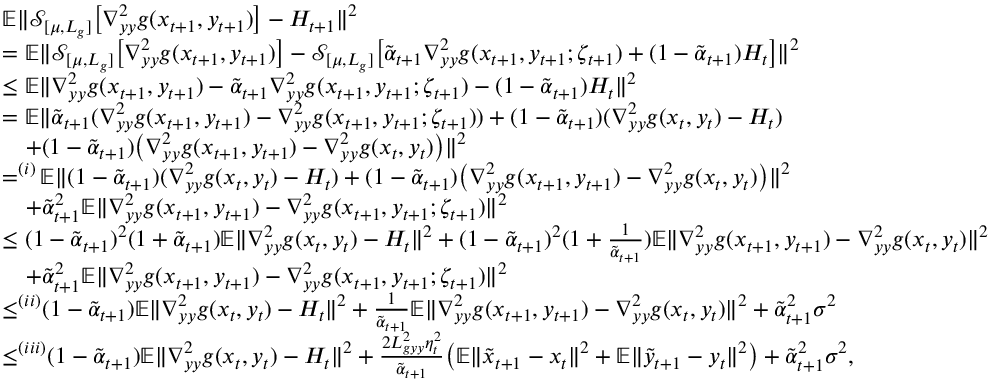<formula> <loc_0><loc_0><loc_500><loc_500>\begin{array} { r l } & { \mathbb { E } \| \mathcal { S } _ { [ \mu , L _ { g } ] } \left [ \nabla _ { y y } ^ { 2 } g ( x _ { t + 1 } , y _ { t + 1 } ) \right ] - H _ { t + 1 } \| ^ { 2 } } \\ & { = \mathbb { E } \| \mathcal { S } _ { [ \mu , L _ { g } ] } \left [ \nabla _ { y y } ^ { 2 } g ( x _ { t + 1 } , y _ { t + 1 } ) \right ] - \mathcal { S } _ { [ \mu , L _ { g } ] } \left [ \tilde { \alpha } _ { t + 1 } \nabla _ { y y } ^ { 2 } g ( x _ { t + 1 } , y _ { t + 1 } ; \zeta _ { t + 1 } ) + ( 1 - \tilde { \alpha } _ { t + 1 } ) H _ { t } \right ] \| ^ { 2 } } \\ & { \leq \mathbb { E } \| \nabla _ { y y } ^ { 2 } g ( x _ { t + 1 } , y _ { t + 1 } ) - \tilde { \alpha } _ { t + 1 } \nabla _ { y y } ^ { 2 } g ( x _ { t + 1 } , y _ { t + 1 } ; \zeta _ { t + 1 } ) - ( 1 - \tilde { \alpha } _ { t + 1 } ) H _ { t } \| ^ { 2 } } \\ & { = \mathbb { E } \| \tilde { \alpha } _ { t + 1 } ( \nabla _ { y y } ^ { 2 } g ( x _ { t + 1 } , y _ { t + 1 } ) - \nabla _ { y y } ^ { 2 } g ( x _ { t + 1 } , y _ { t + 1 } ; \zeta _ { t + 1 } ) ) + ( 1 - \tilde { \alpha } _ { t + 1 } ) ( \nabla _ { y y } ^ { 2 } g ( x _ { t } , y _ { t } ) - H _ { t } ) } \\ & { \quad + ( 1 - \tilde { \alpha } _ { t + 1 } ) \left ( \nabla _ { y y } ^ { 2 } g ( x _ { t + 1 } , y _ { t + 1 } ) - \nabla _ { y y } ^ { 2 } g ( x _ { t } , y _ { t } ) \right ) \| ^ { 2 } } \\ & { = ^ { ( i ) } \mathbb { E } \| ( 1 - \tilde { \alpha } _ { t + 1 } ) ( \nabla _ { y y } ^ { 2 } g ( x _ { t } , y _ { t } ) - H _ { t } ) + ( 1 - \tilde { \alpha } _ { t + 1 } ) \left ( \nabla _ { y y } ^ { 2 } g ( x _ { t + 1 } , y _ { t + 1 } ) - \nabla _ { y y } ^ { 2 } g ( x _ { t } , y _ { t } ) \right ) \| ^ { 2 } } \\ & { \quad + \tilde { \alpha } _ { t + 1 } ^ { 2 } \mathbb { E } \| \nabla _ { y y } ^ { 2 } g ( x _ { t + 1 } , y _ { t + 1 } ) - \nabla _ { y y } ^ { 2 } g ( x _ { t + 1 } , y _ { t + 1 } ; \zeta _ { t + 1 } ) \| ^ { 2 } } \\ & { \leq ( 1 - \tilde { \alpha } _ { t + 1 } ) ^ { 2 } ( 1 + \tilde { \alpha } _ { t + 1 } ) \mathbb { E } \| \nabla _ { y y } ^ { 2 } g ( x _ { t } , y _ { t } ) - H _ { t } \| ^ { 2 } + ( 1 - \tilde { \alpha } _ { t + 1 } ) ^ { 2 } ( 1 + \frac { 1 } { \tilde { \alpha } _ { t + 1 } } ) \mathbb { E } \| \nabla _ { y y } ^ { 2 } g ( x _ { t + 1 } , y _ { t + 1 } ) - \nabla _ { y y } ^ { 2 } g ( x _ { t } , y _ { t } ) \| ^ { 2 } } \\ & { \quad + \tilde { \alpha } _ { t + 1 } ^ { 2 } \mathbb { E } \| \nabla _ { y y } ^ { 2 } g ( x _ { t + 1 } , y _ { t + 1 } ) - \nabla _ { y y } ^ { 2 } g ( x _ { t + 1 } , y _ { t + 1 } ; \zeta _ { t + 1 } ) \| ^ { 2 } } \\ & { \leq ^ { ( i i ) } ( 1 - \tilde { \alpha } _ { t + 1 } ) \mathbb { E } \| \nabla _ { y y } ^ { 2 } g ( x _ { t } , y _ { t } ) - H _ { t } \| ^ { 2 } + \frac { 1 } { \tilde { \alpha } _ { t + 1 } } \mathbb { E } \| \nabla _ { y y } ^ { 2 } g ( x _ { t + 1 } , y _ { t + 1 } ) - \nabla _ { y y } ^ { 2 } g ( x _ { t } , y _ { t } ) \| ^ { 2 } + \tilde { \alpha } _ { t + 1 } ^ { 2 } \sigma ^ { 2 } } \\ & { \leq ^ { ( i i i ) } ( 1 - \tilde { \alpha } _ { t + 1 } ) \mathbb { E } \| \nabla _ { y y } ^ { 2 } g ( x _ { t } , y _ { t } ) - H _ { t } \| ^ { 2 } + \frac { 2 L _ { g y y } ^ { 2 } \eta _ { t } ^ { 2 } } { \tilde { \alpha } _ { t + 1 } } \left ( \mathbb { E } \| \tilde { x } _ { t + 1 } - x _ { t } \| ^ { 2 } + \mathbb { E } \| \tilde { y } _ { t + 1 } - y _ { t } \| ^ { 2 } \right ) + \tilde { \alpha } _ { t + 1 } ^ { 2 } \sigma ^ { 2 } , } \end{array}</formula> 